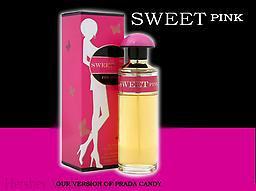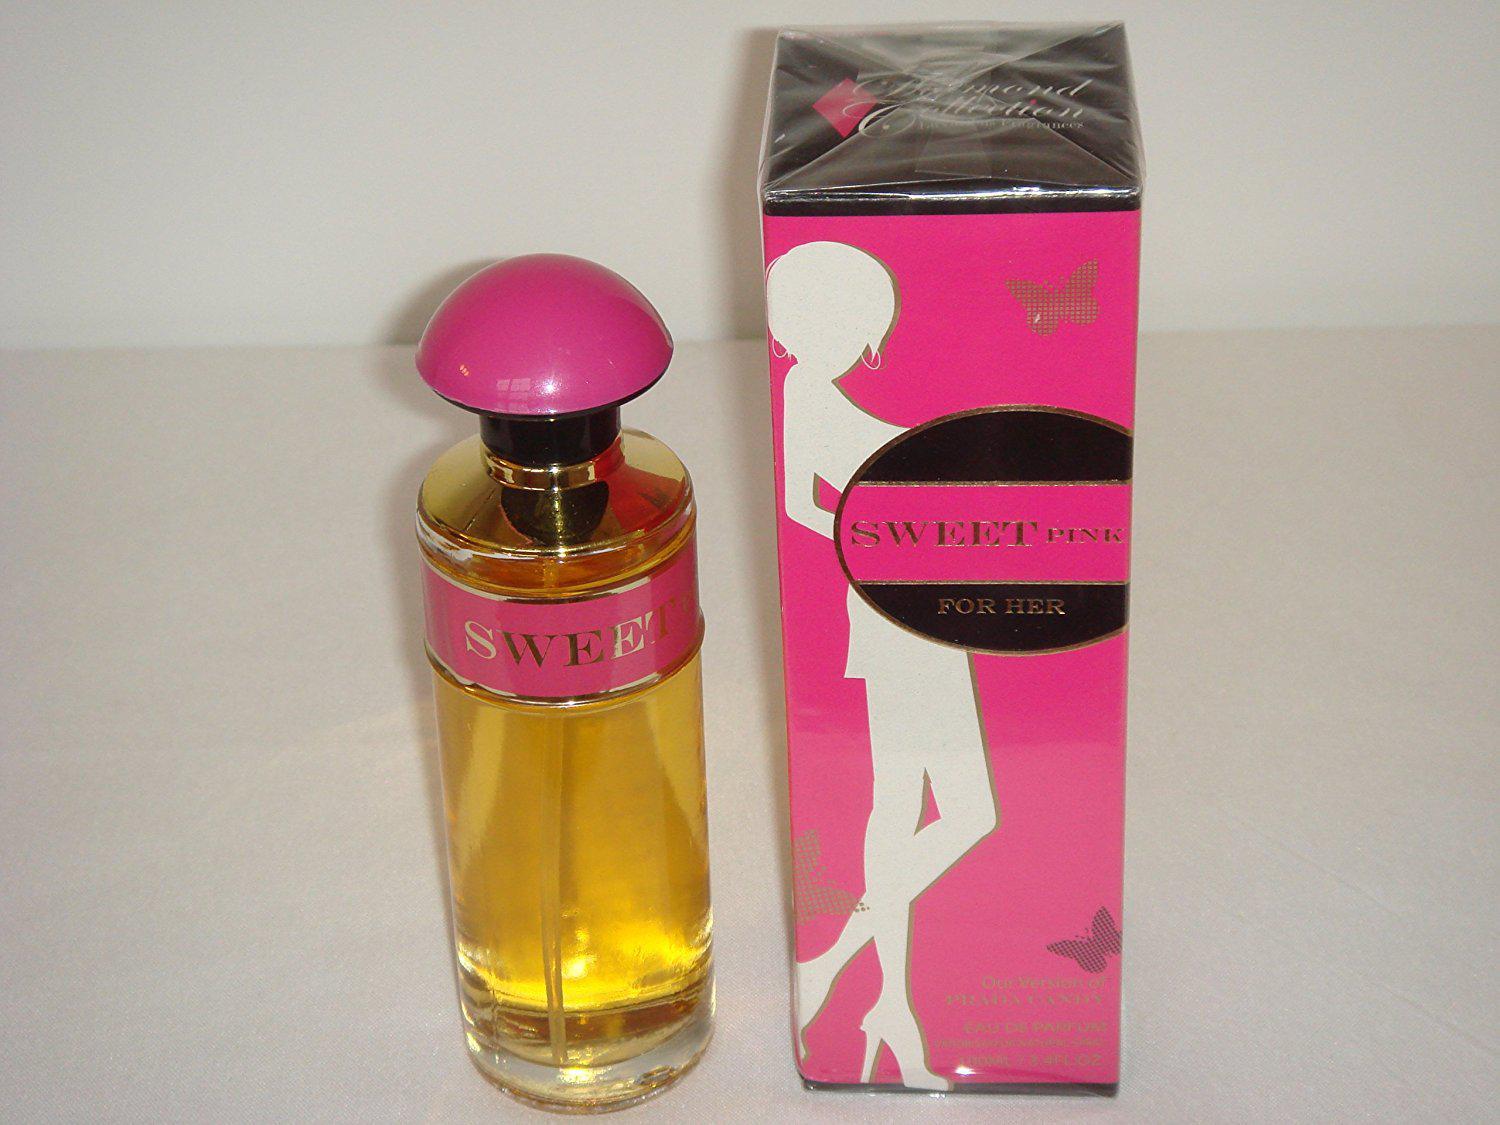The first image is the image on the left, the second image is the image on the right. Examine the images to the left and right. Is the description "The left image features a cylindrical bottle with a hot pink rounded cap standing to the right of an upright hot pink box and slightly overlapping it." accurate? Answer yes or no. Yes. 